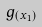<formula> <loc_0><loc_0><loc_500><loc_500>g _ { ( x _ { 1 } ) }</formula> 